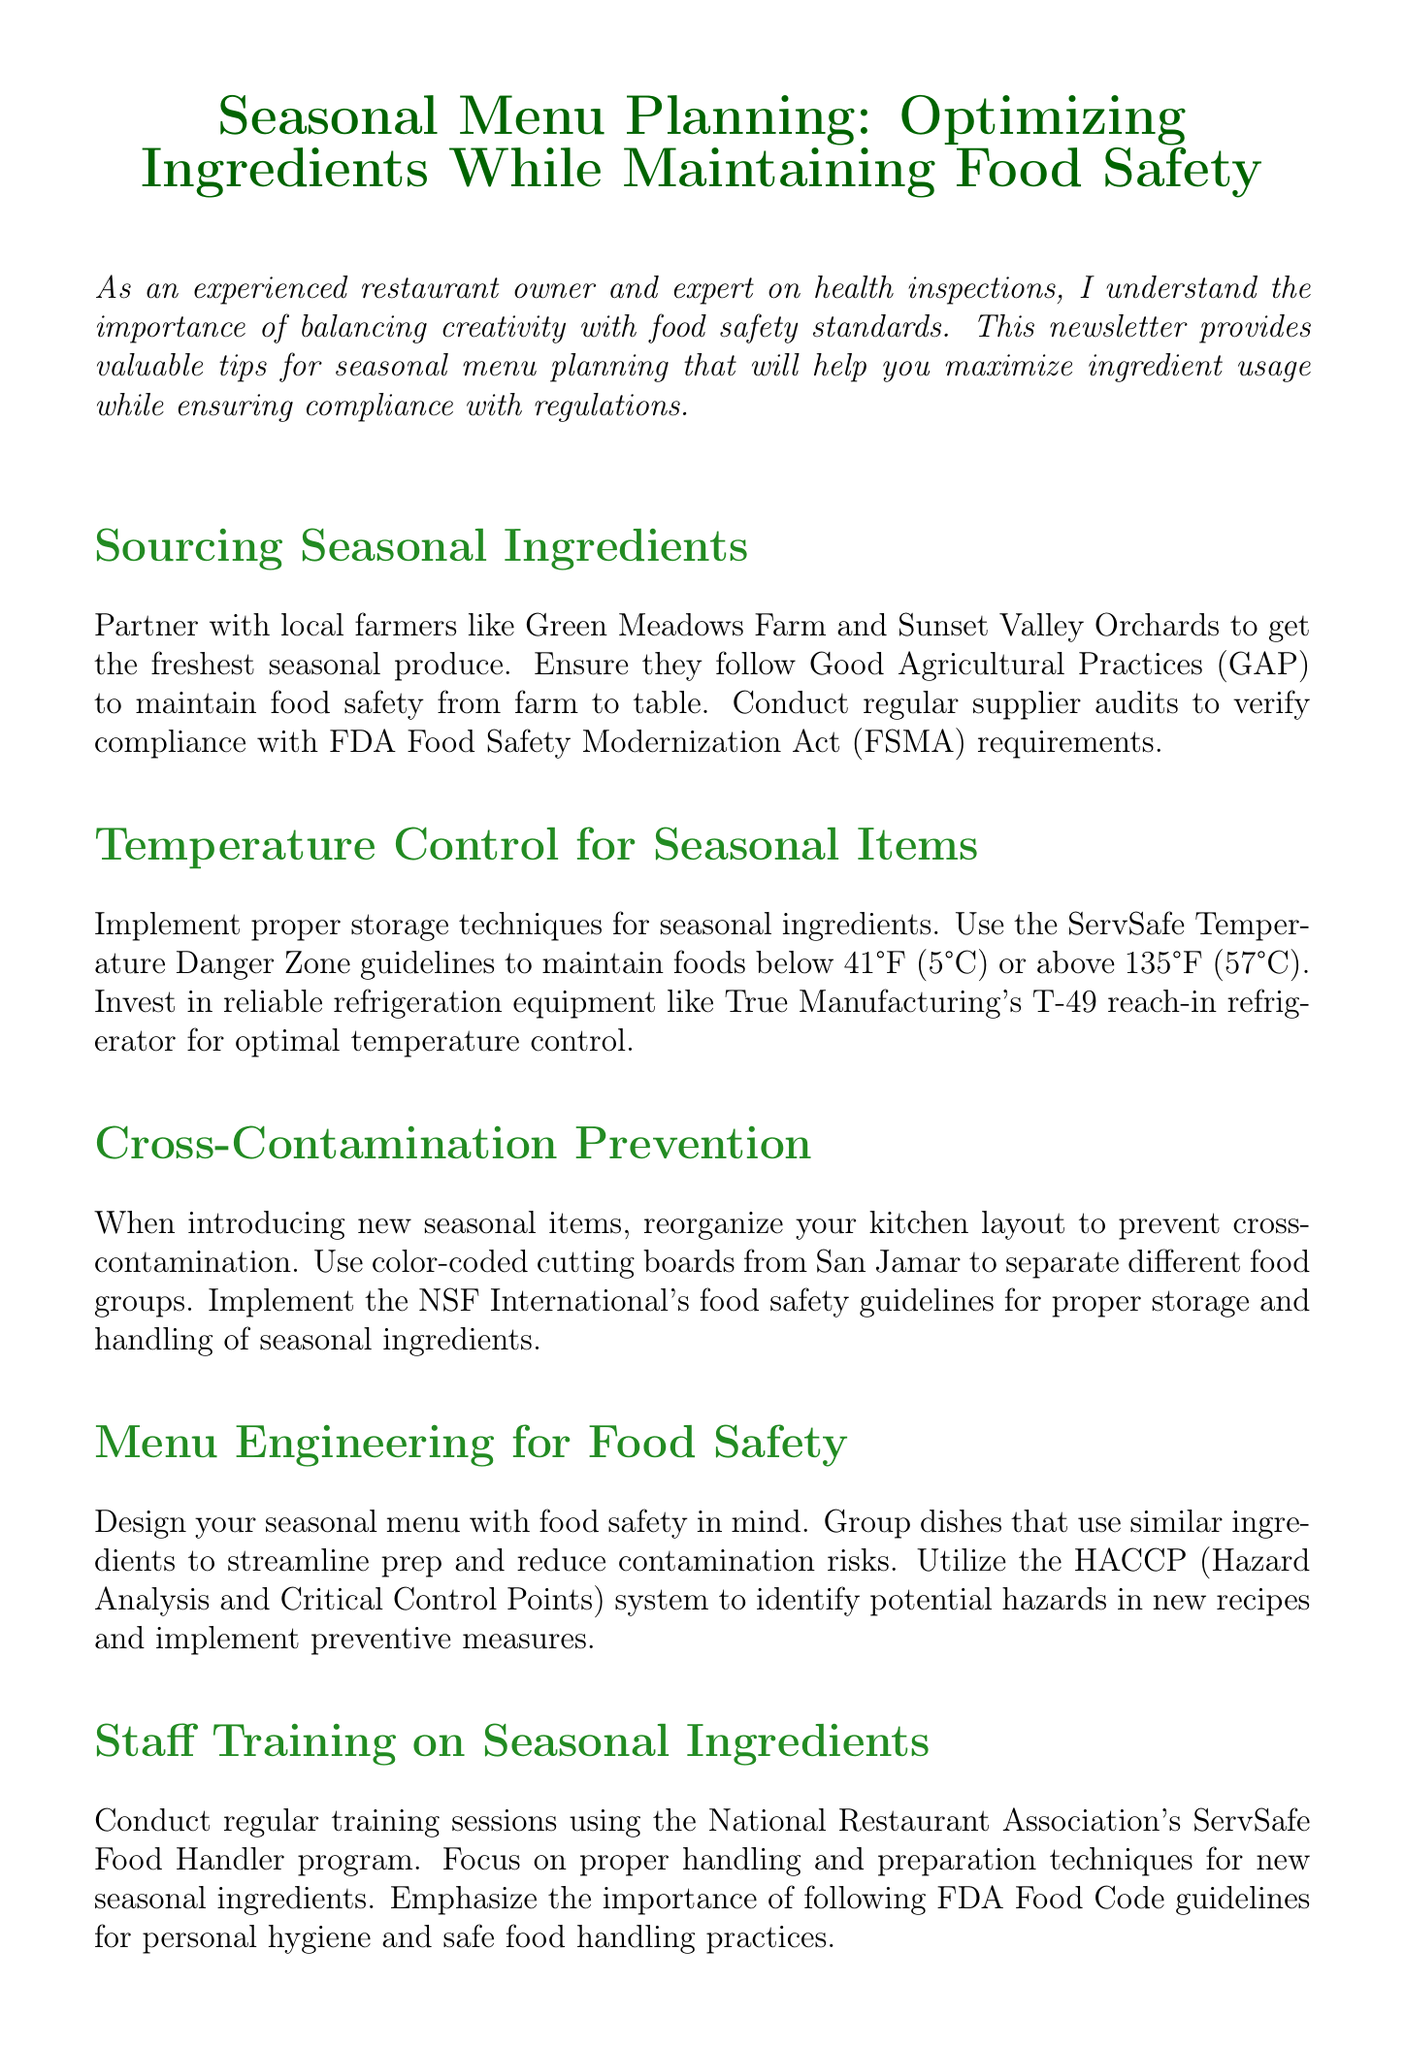What is the title of the newsletter? The title of the newsletter is displayed prominently at the beginning of the document.
Answer: Seasonal Menu Planning: Optimizing Ingredients While Maintaining Food Safety Who should you partner with for seasonal ingredients? The newsletter suggests specific local farms you can partner with for fresh produce.
Answer: Green Meadows Farm and Sunset Valley Orchards What temperature range should seasonal ingredients be stored in? The proper storage temperature is highlighted in the section regarding temperature control.
Answer: Below 41°F (5°C) or above 135°F (57°C) What does HACCP stand for? The acronym is introduced in the menu engineering section as part of food safety planning.
Answer: Hazard Analysis and Critical Control Points What training program should staff use for food handling? The newsletter specifies a program to conduct regular training sessions on food handling.
Answer: National Restaurant Association's ServSafe Food Handler program How often should the allergen matrix be updated? The newsletter advises on the frequency of allergen matrix updates with menu changes.
Answer: With each menu change What type of packaging should be used for takeout orders? The document mentions sustainable practices for food safety and takeout orders.
Answer: Biodegradable packaging from World Centric Which organization's guidelines are referenced for cross-contamination prevention? The source of guidelines for preventing cross-contamination is specified in the document.
Answer: NSF International 